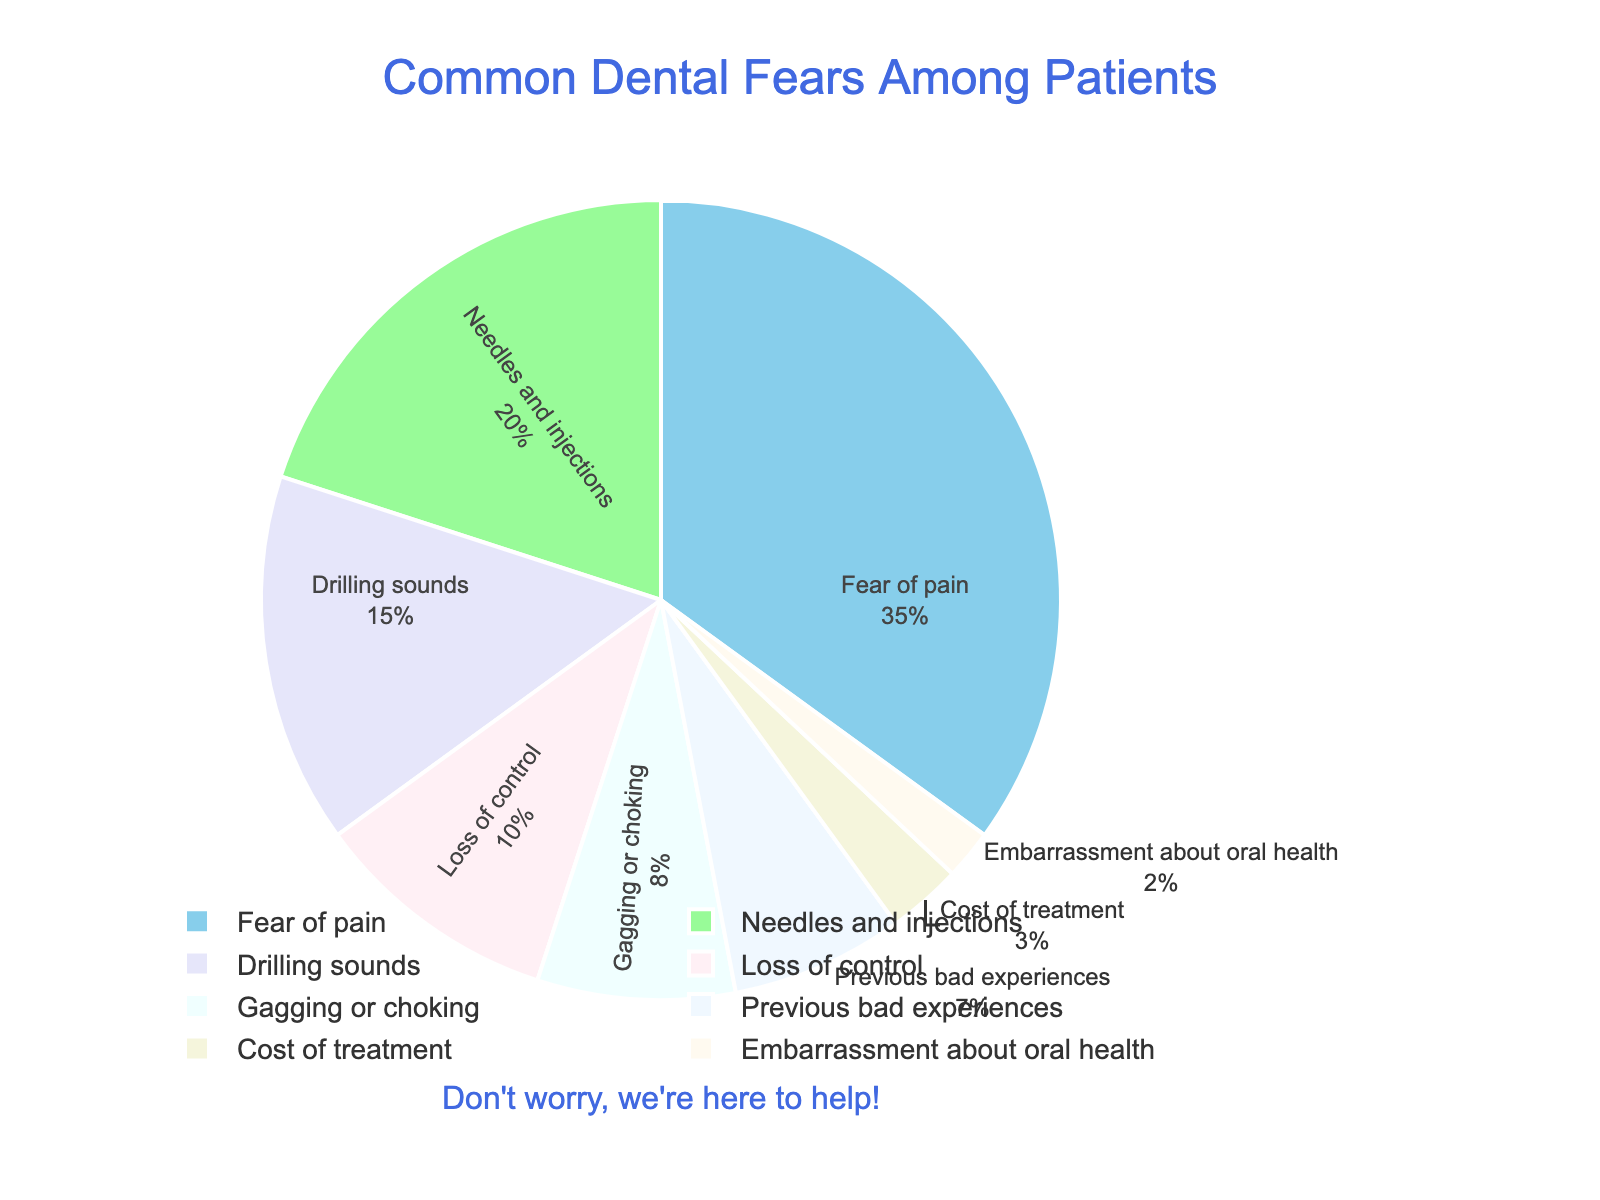What is the most common dental fear among patients? Look at the largest portion of the pie chart. The segment labeled "Fear of pain" takes up 35% of the chart, making it the most common fear.
Answer: Fear of pain Which dental fear is least common? Look at the smallest segment of the pie chart. The segment labeled "Embarrassment about oral health" is the smallest portion, making it the least common fear.
Answer: Embarrassment about oral health How much higher is the percentage of people who fear needles and injections compared to those who are embarrassed about their oral health? Subtract the percentage of people fearing embarrassment (2%) from those who fear needles and injections (20%). 20% - 2% = 18%.
Answer: 18% What percentage of patients fear either the cost of treatment or embarrassment about oral health? Sum the percentages of patients fearing cost of treatment (3%) and embarrassment about oral health (2%). 3% + 2% = 5%.
Answer: 5% What is the combined percentage of patients fearing drilling sounds, loss of control, and gagging or choking? Add the percentages for drilling sounds (15%), loss of control (10%), and gagging or choking (8%). 15% + 10% + 8% = 33%.
Answer: 33% Which fear is more common: previous bad experiences or gagging or choking? Compare the percentages of previous bad experiences (7%) and gagging or choking (8%). Gagging or choking is more common.
Answer: Gagging or choking How much greater is the fear of pain compared to the fear of cost of treatment? Subtract the percentage of people fearing the cost of treatment (3%) from those fearing pain (35%). 35% - 3% = 32%.
Answer: 32% What is the difference in percentage between those who fear needles and those who fear drilling sounds? Subtract the percentage of those fearing drilling sounds (15%) from those who fear needles (20%). 20% - 15% = 5%.
Answer: 5% Is the fear of previous bad experiences greater than fear of drilling sounds? Compare the percentages of previous bad experiences (7%) to drilling sounds (15%). The fear of drilling sounds is greater.
Answer: No What is the average percentage of fear for the groups fearing needles, drilling sounds, and loss of control? Add the percentages of needles (20%), drilling sounds (15%), and loss of control (10%) and then divide by 3. (20% + 15% + 10%) / 3 = 45% / 3 = 15%.
Answer: 15% 